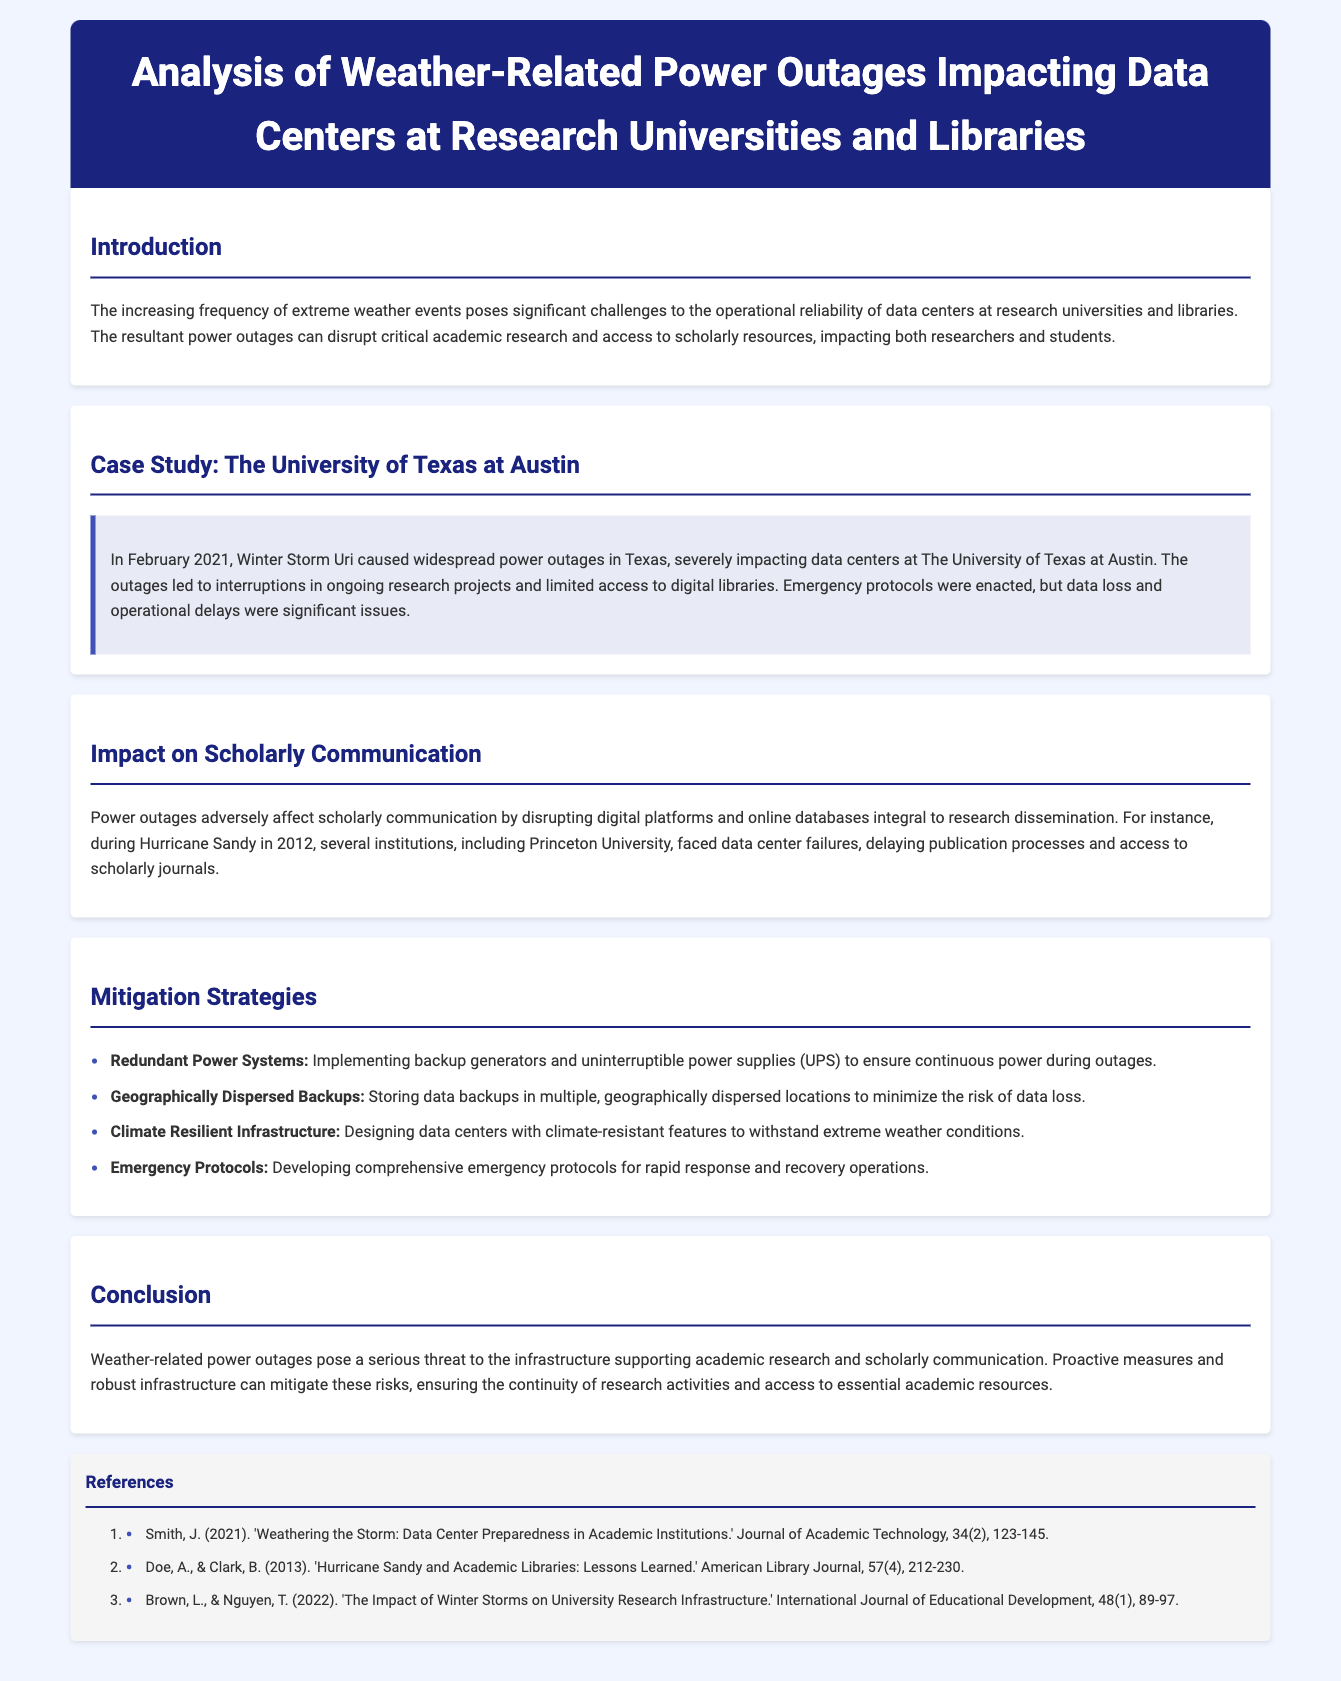What was the name of the winter storm that impacted Texas in February 2021? The document mentions that Winter Storm Uri caused widespread power outages in Texas.
Answer: Winter Storm Uri What university experienced significant impact from Winter Storm Uri? The University of Texas at Austin is highlighted in the case study as experiencing severe impacts from the storm.
Answer: The University of Texas at Austin What year did Hurricane Sandy occur? The document states that Hurricane Sandy occurred in 2012, impacting several institutions.
Answer: 2012 What are two mitigation strategies mentioned in the document? The document lists several strategies including Redundant Power Systems and Geographically Dispersed Backups.
Answer: Redundant Power Systems, Geographically Dispersed Backups What is one major consequence of power outages highlighted in the document? The document indicates that power outages disrupt critical academic research and access to scholarly resources.
Answer: Disruption of academic research What is the overarching theme of the document? The document discusses the impact of weather-related power outages on data centers in academic settings and their implications for scholarly communication.
Answer: Impact of weather-related power outages Which journal article discusses lessons learned from Hurricane Sandy? The reference indicates that the article by Doe and Clark titled 'Hurricane Sandy and Academic Libraries: Lessons Learned' addresses this topic.
Answer: 'Hurricane Sandy and Academic Libraries: Lessons Learned' What critical infrastructure issue does the document address? The document identifies the risk of power outages due to extreme weather as a significant issue for data centers.
Answer: Infrastructure risk due to power outages 